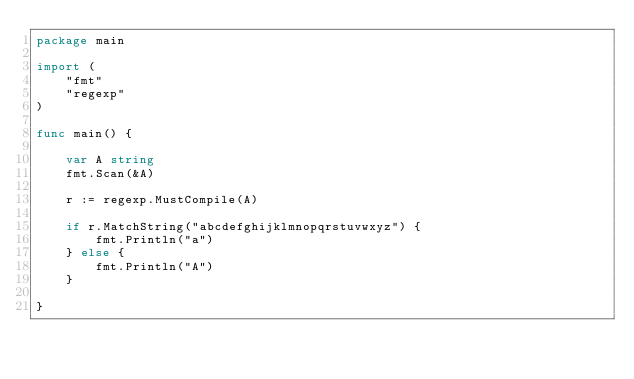Convert code to text. <code><loc_0><loc_0><loc_500><loc_500><_Go_>package main

import (
	"fmt"
	"regexp"
)

func main() {

	var A string
	fmt.Scan(&A)

	r := regexp.MustCompile(A)

	if r.MatchString("abcdefghijklmnopqrstuvwxyz") {
		fmt.Println("a")
	} else {
		fmt.Println("A")
	}

}
</code> 